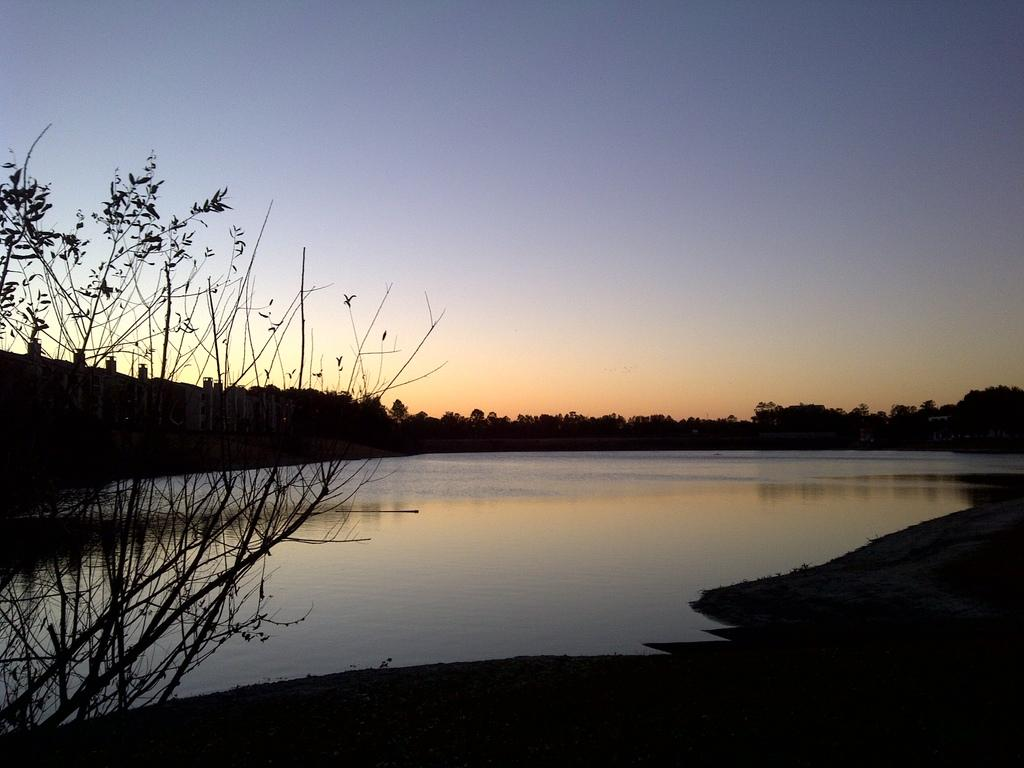What type of natural feature can be seen in the image? There is a lake in the image. What other natural elements are present in the image? There are trees in the image. What type of list can be seen in the image? There is no list present in the image; it features a lake and trees. How does the image convey a sense of comfort? The image does not convey a sense of comfort, as it only shows a lake and trees. 